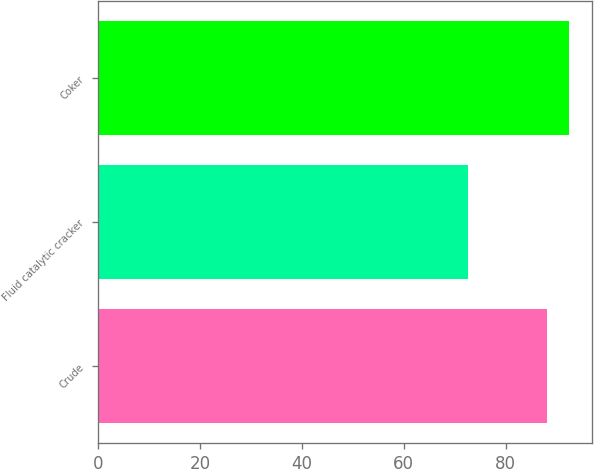Convert chart. <chart><loc_0><loc_0><loc_500><loc_500><bar_chart><fcel>Crude<fcel>Fluid catalytic cracker<fcel>Coker<nl><fcel>88.2<fcel>72.7<fcel>92.4<nl></chart> 